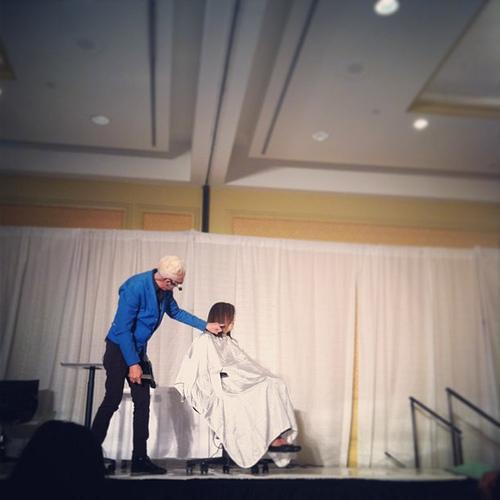How many people are on stage?
Give a very brief answer. 2. 